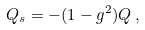<formula> <loc_0><loc_0><loc_500><loc_500>Q _ { s } = - ( 1 - g ^ { 2 } ) Q \, ,</formula> 